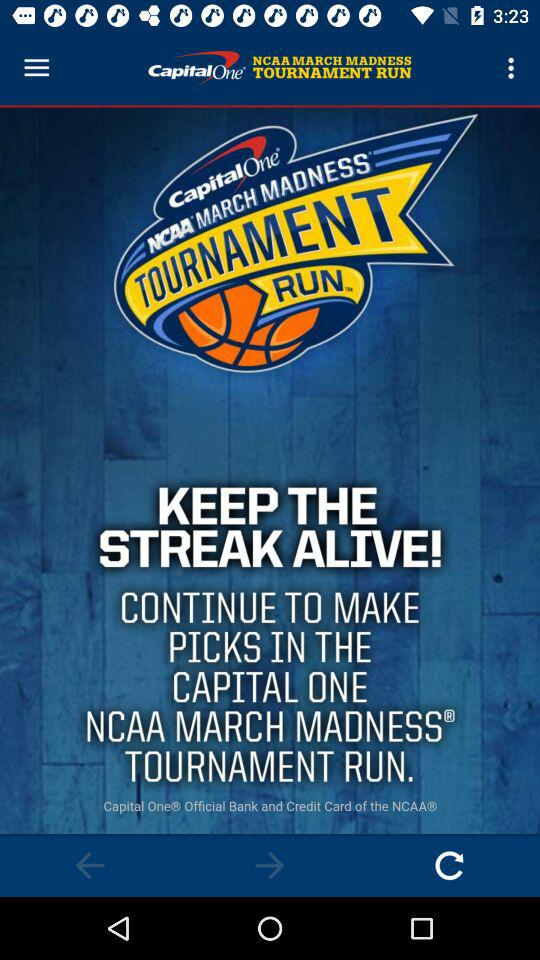What is the application name? The application name is "Capital One". 